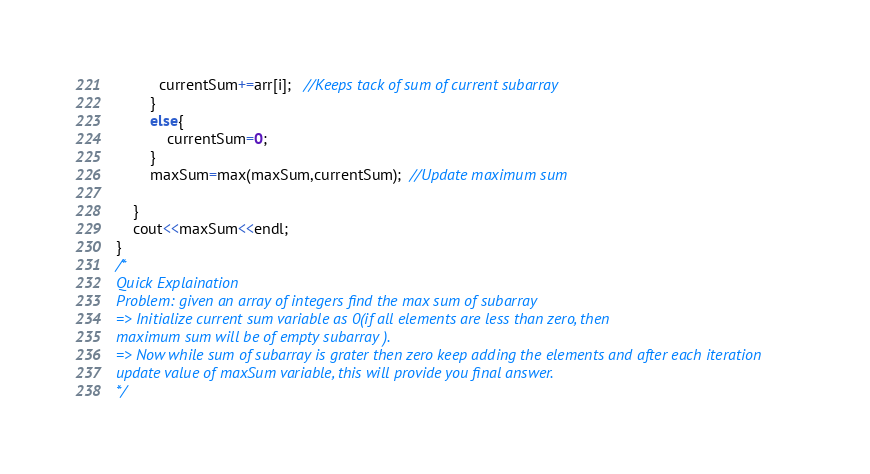<code> <loc_0><loc_0><loc_500><loc_500><_C++_>          currentSum+=arr[i];   //Keeps tack of sum of current subarray 
        }
        else{
            currentSum=0;
        }
        maxSum=max(maxSum,currentSum);  //Update maximum sum

    }
    cout<<maxSum<<endl;
}
/*
Quick Explaination
Problem: given an array of integers find the max sum of subarray
=> Initialize current sum variable as 0(if all elements are less than zero, then 
maximum sum will be of empty subarray ).
=> Now while sum of subarray is grater then zero keep adding the elements and after each iteration
update value of maxSum variable, this will provide you final answer.
*/</code> 